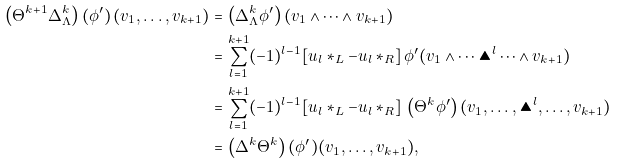<formula> <loc_0><loc_0><loc_500><loc_500>\left ( \Theta ^ { k + 1 } \Delta _ { \Lambda } ^ { k } \right ) \left ( \phi ^ { \prime } \right ) ( v _ { 1 } , \dots , v _ { k + 1 } ) = & \, \left ( \Delta ^ { k } _ { \Lambda } \phi ^ { \prime } \right ) ( v _ { 1 } \wedge \dots \wedge v _ { k + 1 } ) \\ = & \, \sum _ { l = 1 } ^ { k + 1 } ( - 1 ) ^ { l - 1 } [ u _ { l } * _ { L } - u _ { l } \, * _ { R } ] \, \phi ^ { \prime } ( v _ { 1 } \wedge \dots \blacktriangle ^ { l } \dots \wedge v _ { k + 1 } ) \\ = & \, \sum _ { l = 1 } ^ { k + 1 } ( - 1 ) ^ { l - 1 } [ u _ { l } * _ { L } - u _ { l } \, * _ { R } ] \, \left ( \Theta ^ { k } \phi ^ { \prime } \right ) ( v _ { 1 } , \dots , \blacktriangle ^ { l } , \dots , v _ { k + 1 } ) \\ = & \, \left ( \Delta ^ { k } \Theta ^ { k } \right ) ( \phi ^ { \prime } ) ( v _ { 1 } , \dots , v _ { k + 1 } ) ,</formula> 